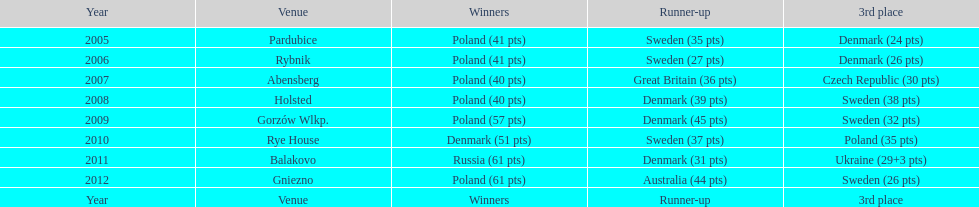Which team holds the record for the most third-place victories in the speedway junior world championship from 2005 to 2012? Sweden. Help me parse the entirety of this table. {'header': ['Year', 'Venue', 'Winners', 'Runner-up', '3rd place'], 'rows': [['2005', 'Pardubice', 'Poland (41 pts)', 'Sweden (35 pts)', 'Denmark (24 pts)'], ['2006', 'Rybnik', 'Poland (41 pts)', 'Sweden (27 pts)', 'Denmark (26 pts)'], ['2007', 'Abensberg', 'Poland (40 pts)', 'Great Britain (36 pts)', 'Czech Republic (30 pts)'], ['2008', 'Holsted', 'Poland (40 pts)', 'Denmark (39 pts)', 'Sweden (38 pts)'], ['2009', 'Gorzów Wlkp.', 'Poland (57 pts)', 'Denmark (45 pts)', 'Sweden (32 pts)'], ['2010', 'Rye House', 'Denmark (51 pts)', 'Sweden (37 pts)', 'Poland (35 pts)'], ['2011', 'Balakovo', 'Russia (61 pts)', 'Denmark (31 pts)', 'Ukraine (29+3 pts)'], ['2012', 'Gniezno', 'Poland (61 pts)', 'Australia (44 pts)', 'Sweden (26 pts)'], ['Year', 'Venue', 'Winners', 'Runner-up', '3rd place']]} 